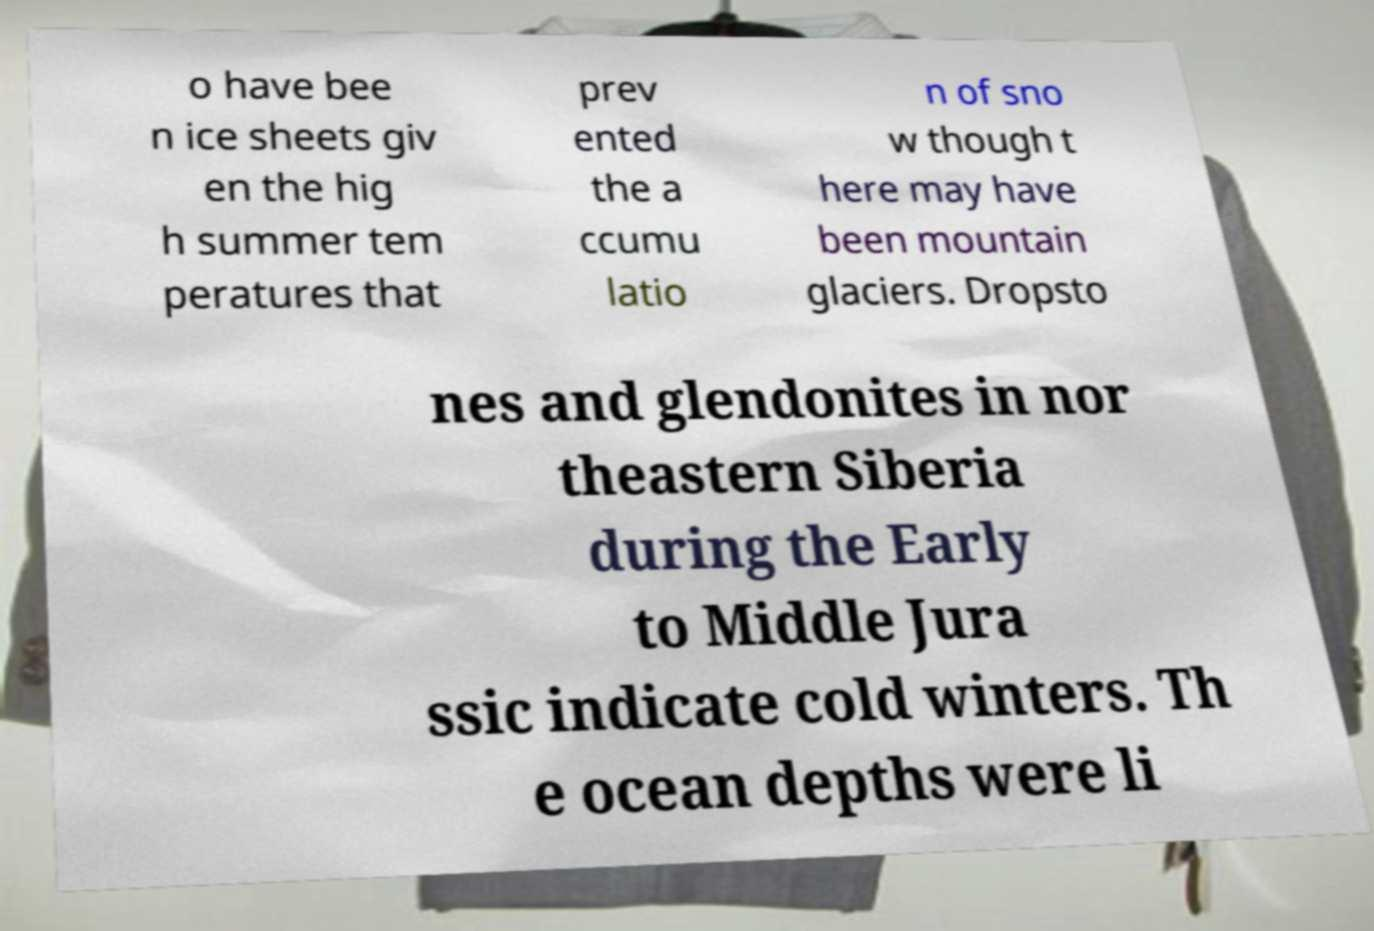Please identify and transcribe the text found in this image. o have bee n ice sheets giv en the hig h summer tem peratures that prev ented the a ccumu latio n of sno w though t here may have been mountain glaciers. Dropsto nes and glendonites in nor theastern Siberia during the Early to Middle Jura ssic indicate cold winters. Th e ocean depths were li 